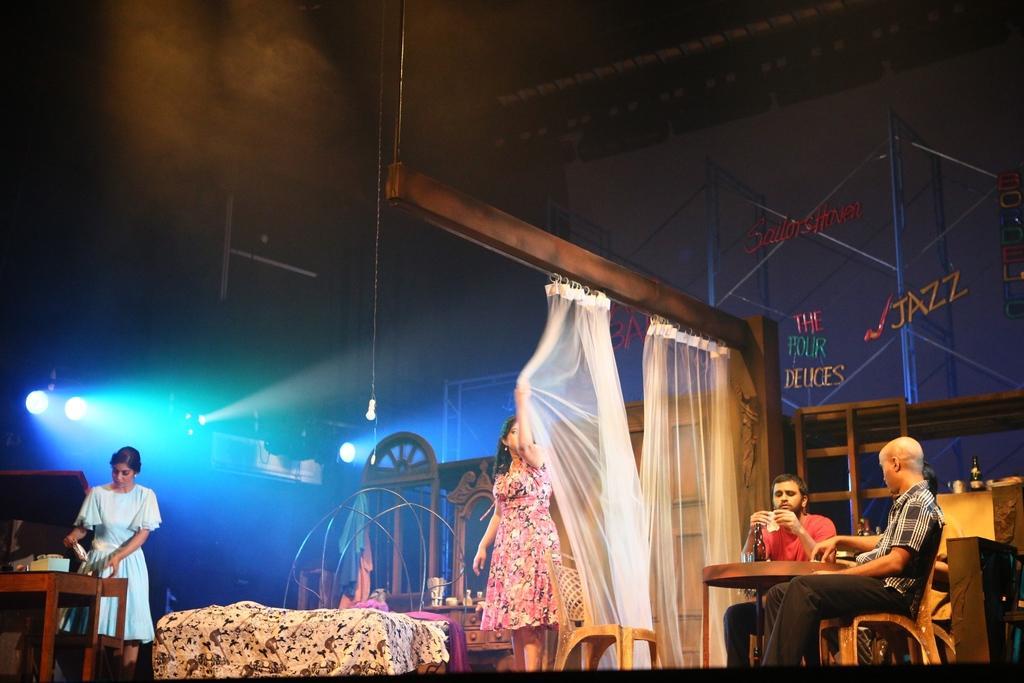Could you give a brief overview of what you see in this image? In this image there is one women standing on the left side of this image is wearing white color dress and there is one women standing in the middle of this image ,and there are two persons sitting on the chairs on the right side of this image. There are white color curtains in the middle of this image. There is a table on the left side of this image and right side of this image as well. There is a wall in the background. There are some lights on the left side of this image and middle of this image as well. There are some wooden objects as we can see in the middle of this image. 